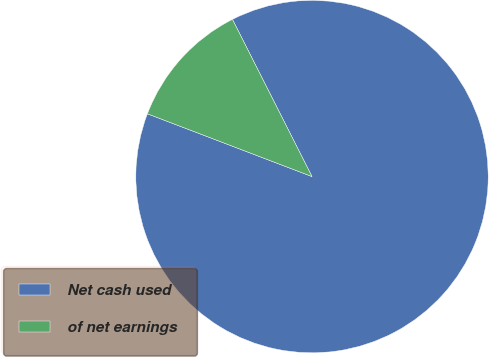Convert chart. <chart><loc_0><loc_0><loc_500><loc_500><pie_chart><fcel>Net cash used<fcel>of net earnings<nl><fcel>88.26%<fcel>11.74%<nl></chart> 